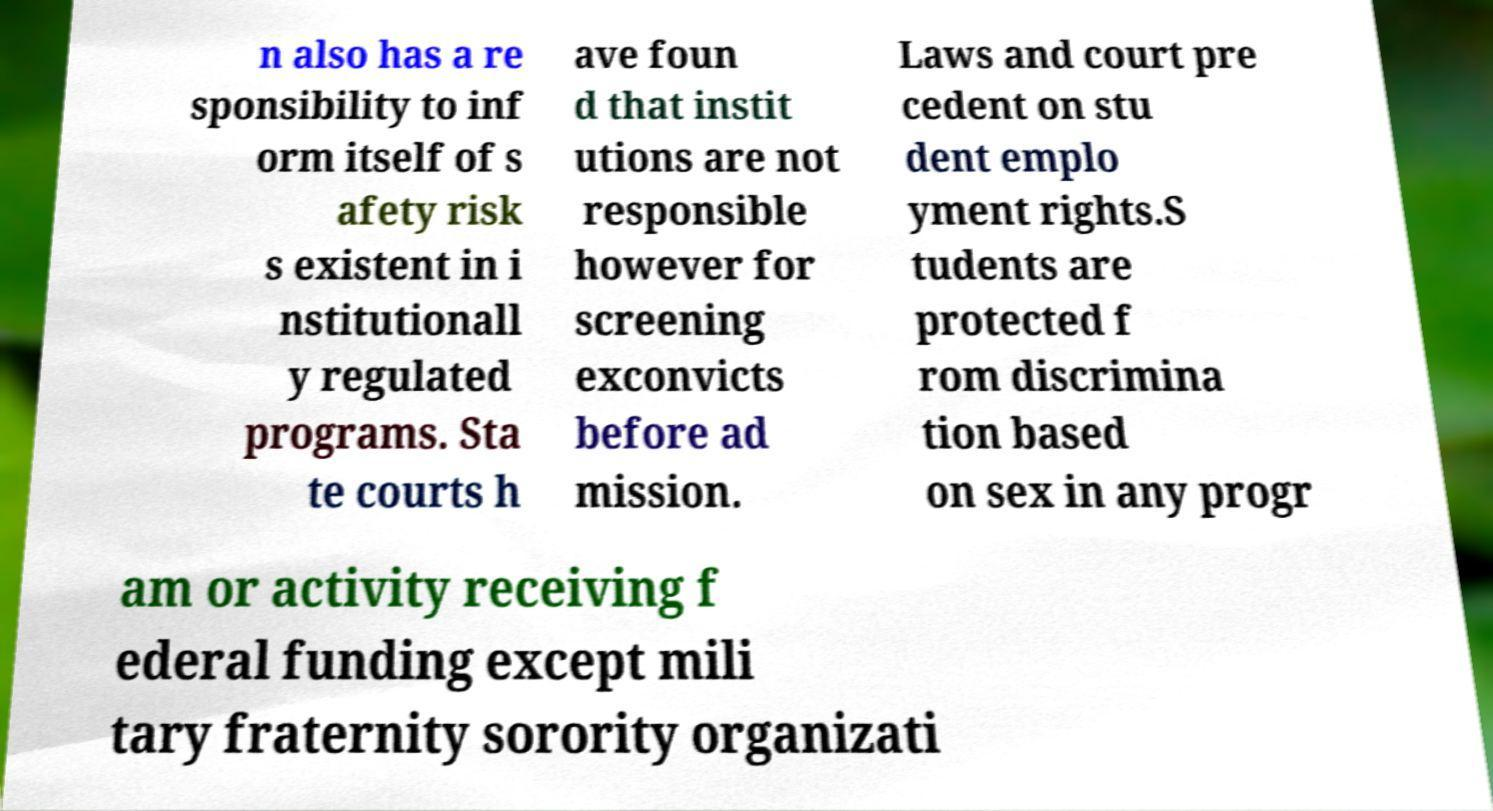For documentation purposes, I need the text within this image transcribed. Could you provide that? n also has a re sponsibility to inf orm itself of s afety risk s existent in i nstitutionall y regulated programs. Sta te courts h ave foun d that instit utions are not responsible however for screening exconvicts before ad mission. Laws and court pre cedent on stu dent emplo yment rights.S tudents are protected f rom discrimina tion based on sex in any progr am or activity receiving f ederal funding except mili tary fraternity sorority organizati 